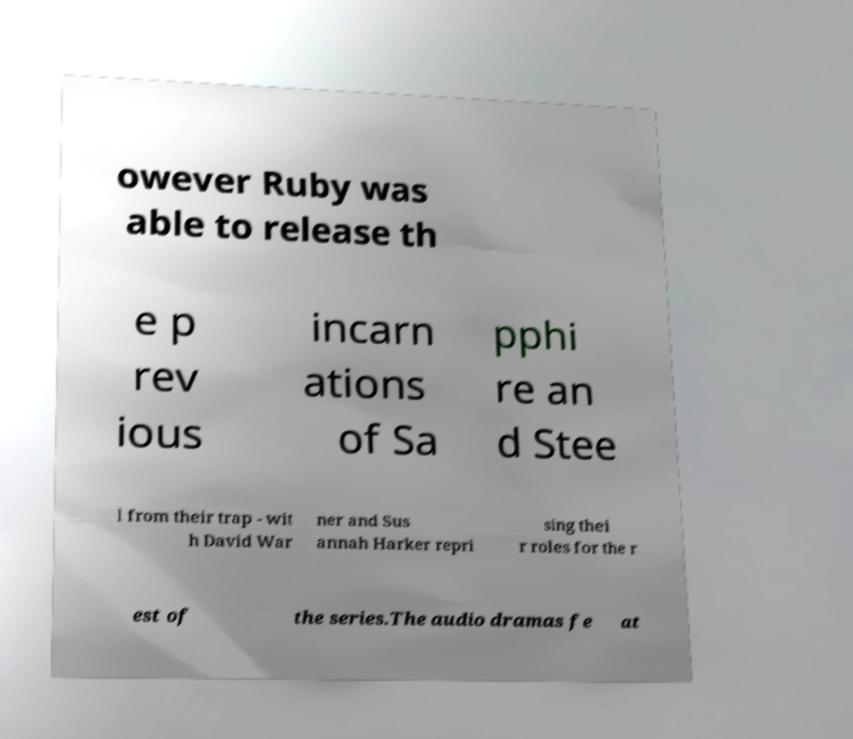For documentation purposes, I need the text within this image transcribed. Could you provide that? owever Ruby was able to release th e p rev ious incarn ations of Sa pphi re an d Stee l from their trap - wit h David War ner and Sus annah Harker repri sing thei r roles for the r est of the series.The audio dramas fe at 